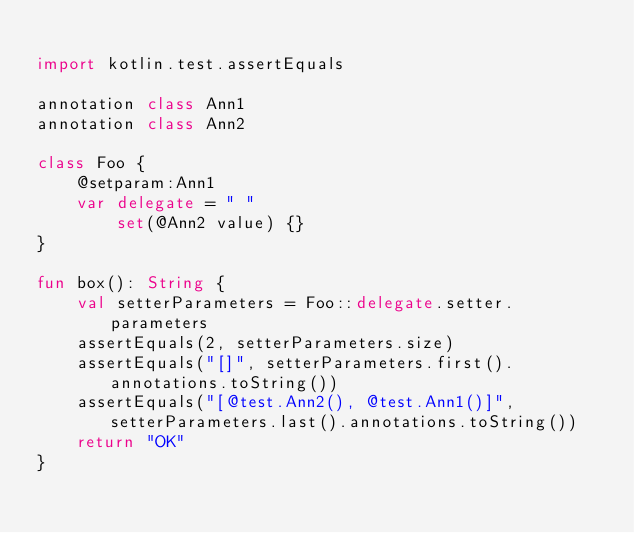Convert code to text. <code><loc_0><loc_0><loc_500><loc_500><_Kotlin_>
import kotlin.test.assertEquals

annotation class Ann1
annotation class Ann2

class Foo {
    @setparam:Ann1
    var delegate = " "
        set(@Ann2 value) {}
}

fun box(): String {
    val setterParameters = Foo::delegate.setter.parameters
    assertEquals(2, setterParameters.size)
    assertEquals("[]", setterParameters.first().annotations.toString())
    assertEquals("[@test.Ann2(), @test.Ann1()]", setterParameters.last().annotations.toString())
    return "OK"
}
</code> 